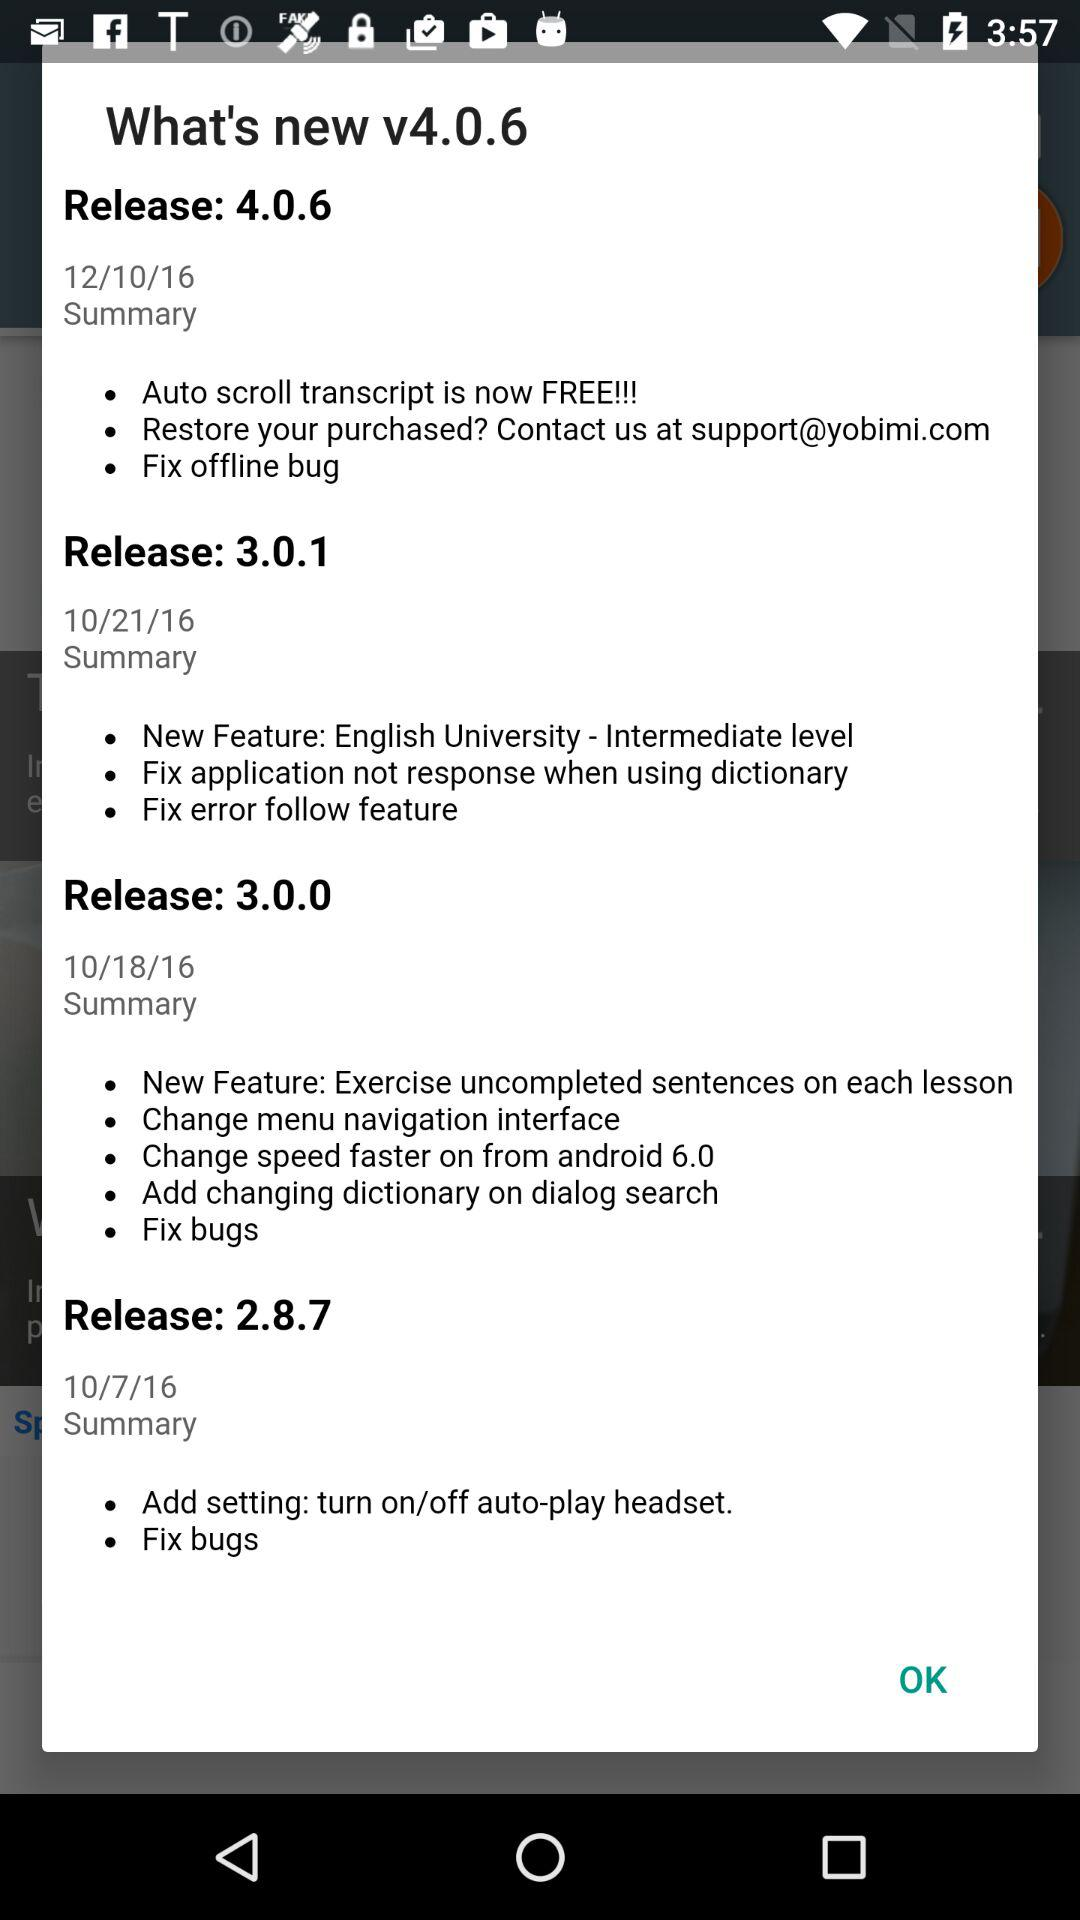What is the new version? The new version is v4.0.6. 